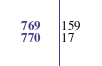Convert code to text. <code><loc_0><loc_0><loc_500><loc_500><_SQL_>159
17</code> 